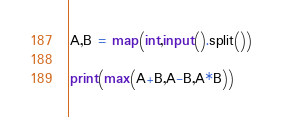<code> <loc_0><loc_0><loc_500><loc_500><_Python_>A,B = map(int,input().split())

print(max(A+B,A-B,A*B))</code> 